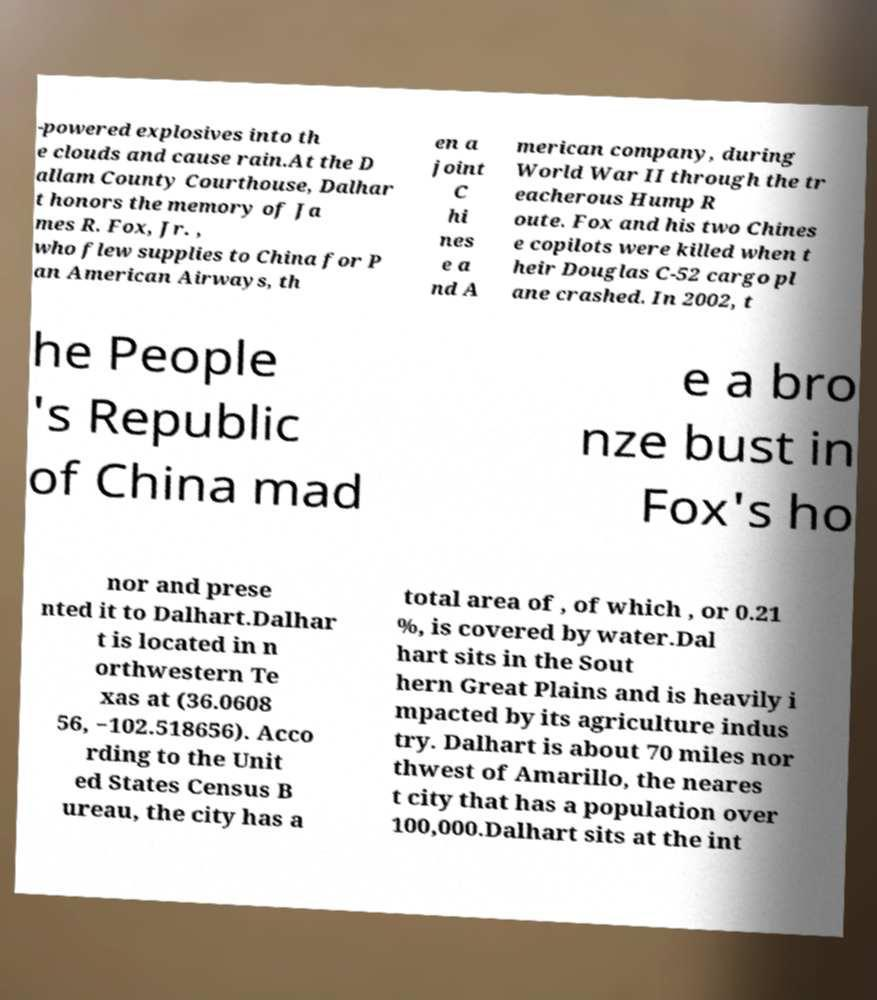Can you accurately transcribe the text from the provided image for me? -powered explosives into th e clouds and cause rain.At the D allam County Courthouse, Dalhar t honors the memory of Ja mes R. Fox, Jr. , who flew supplies to China for P an American Airways, th en a joint C hi nes e a nd A merican company, during World War II through the tr eacherous Hump R oute. Fox and his two Chines e copilots were killed when t heir Douglas C-52 cargo pl ane crashed. In 2002, t he People 's Republic of China mad e a bro nze bust in Fox's ho nor and prese nted it to Dalhart.Dalhar t is located in n orthwestern Te xas at (36.0608 56, −102.518656). Acco rding to the Unit ed States Census B ureau, the city has a total area of , of which , or 0.21 %, is covered by water.Dal hart sits in the Sout hern Great Plains and is heavily i mpacted by its agriculture indus try. Dalhart is about 70 miles nor thwest of Amarillo, the neares t city that has a population over 100,000.Dalhart sits at the int 